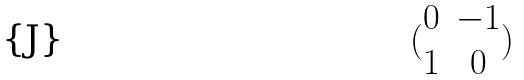<formula> <loc_0><loc_0><loc_500><loc_500>( \begin{matrix} 0 & - 1 \\ 1 & 0 \end{matrix} )</formula> 